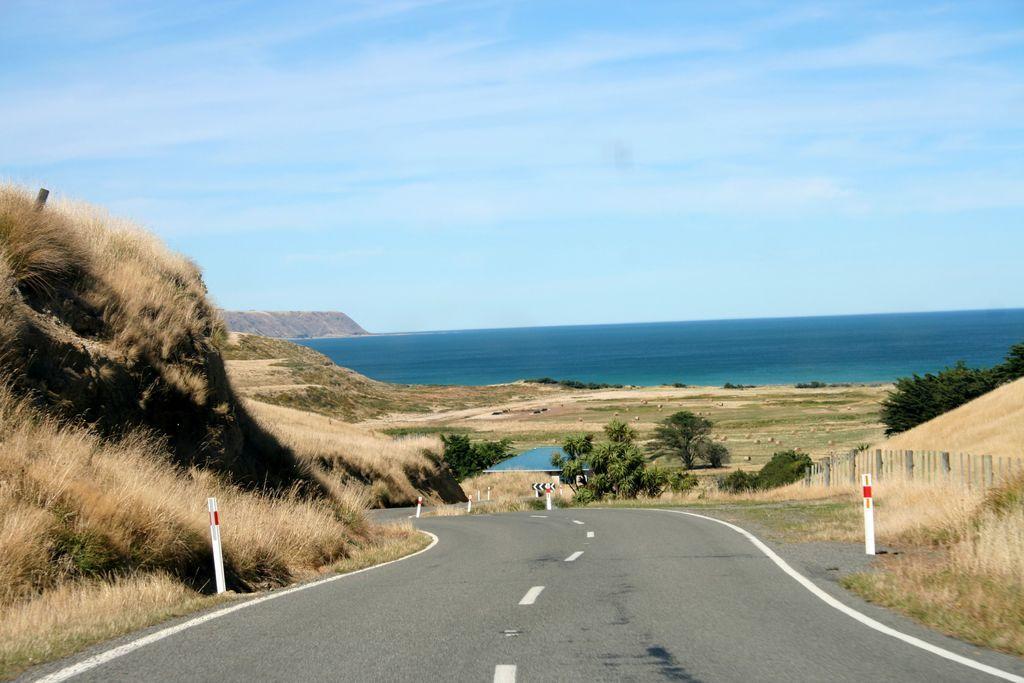Describe this image in one or two sentences. This image is clicked on the road. On the either sides of the road there are rods, plants and grass on the hills. In the background there is the water. At the top there is the sky. In the center there are trees. 